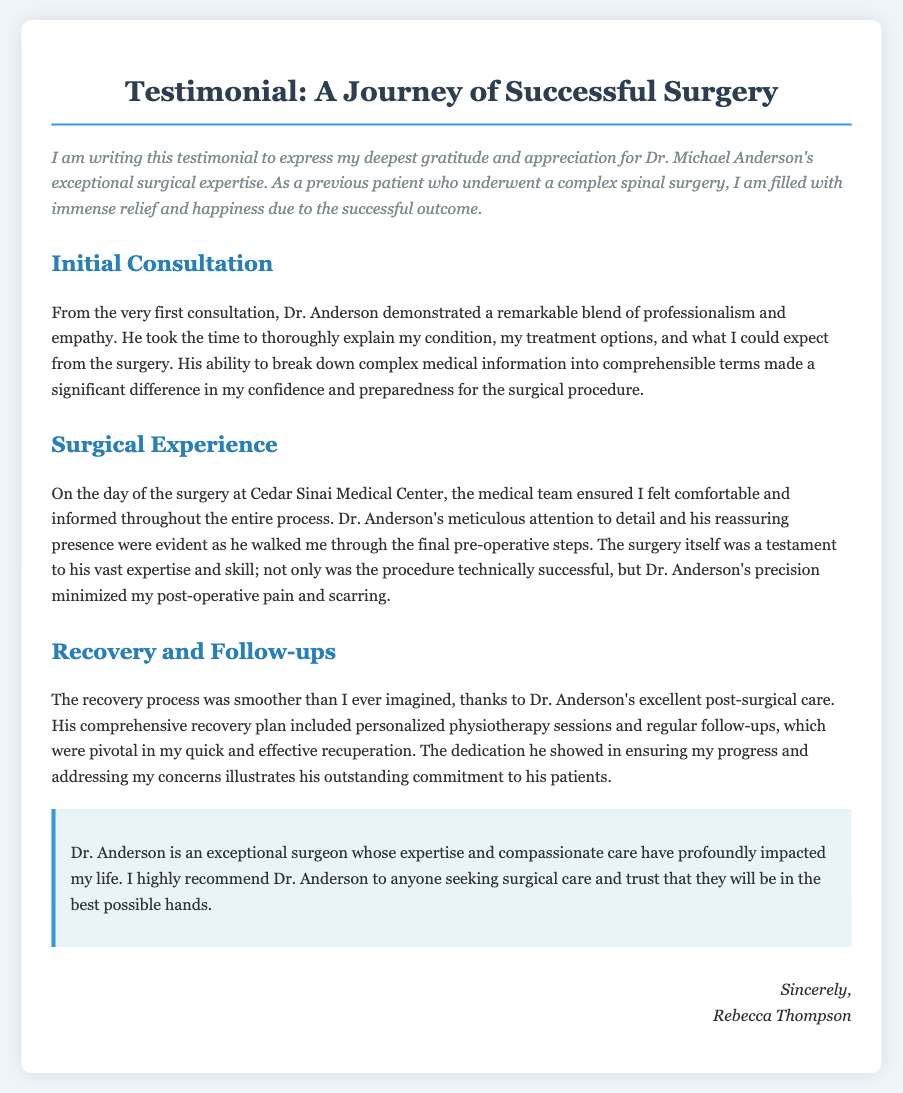What is the surgeon's name? The name of the surgeon mentioned in the document is Dr. Michael Anderson.
Answer: Dr. Michael Anderson What type of surgery did the patient undergo? The document states that the patient underwent a complex spinal surgery.
Answer: spinal surgery Where did the surgery take place? The surgery was conducted at Cedar Sinai Medical Center, as mentioned in the document.
Answer: Cedar Sinai Medical Center What is highlighted as a benefit of Dr. Anderson's surgical skill? The document mentions that Dr. Anderson's precision minimized post-operative pain and scarring.
Answer: minimized post-operative pain and scarring What was included in Dr. Anderson's recovery plan? The recovery plan included personalized physiotherapy sessions and regular follow-ups.
Answer: personalized physiotherapy sessions and regular follow-ups How does the patient describe Dr. Anderson's initial consultation? The patient describes the initial consultation as a remarkable blend of professionalism and empathy.
Answer: professionalism and empathy What is the patient’s recommendation for Dr. Anderson? The patient highly recommends Dr. Anderson to anyone seeking surgical care.
Answer: highly recommend How does the patient feel about their recovery process? The patient felt that the recovery process was smoother than they ever imagined.
Answer: smoother than imagined 